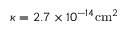<formula> <loc_0><loc_0><loc_500><loc_500>\kappa = 2 . 7 \times 1 0 ^ { - 1 4 } c m ^ { 2 }</formula> 